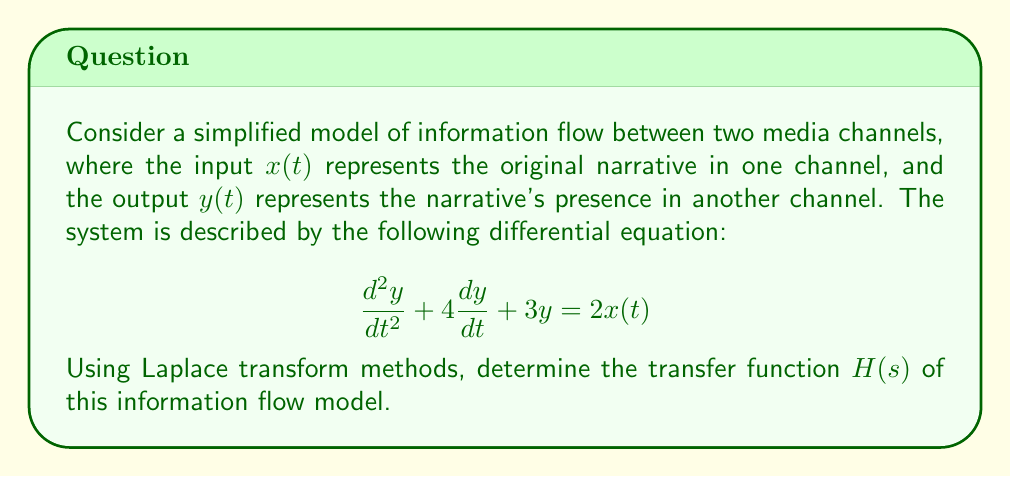Can you answer this question? To find the transfer function using Laplace transform methods, we follow these steps:

1) First, we take the Laplace transform of both sides of the differential equation. Let $X(s)$ and $Y(s)$ be the Laplace transforms of $x(t)$ and $y(t)$ respectively.

   $$\mathcal{L}\left\{\frac{d^2y}{dt^2} + 4\frac{dy}{dt} + 3y\right\} = \mathcal{L}\{2x(t)\}$$

2) Using the properties of Laplace transforms:

   $$s^2Y(s) - sy(0) - y'(0) + 4[sY(s) - y(0)] + 3Y(s) = 2X(s)$$

3) Assuming zero initial conditions (i.e., $y(0) = 0$ and $y'(0) = 0$), we get:

   $$s^2Y(s) + 4sY(s) + 3Y(s) = 2X(s)$$

4) Factoring out $Y(s)$:

   $$Y(s)(s^2 + 4s + 3) = 2X(s)$$

5) The transfer function $H(s)$ is defined as the ratio of output to input in the s-domain:

   $$H(s) = \frac{Y(s)}{X(s)} = \frac{2}{s^2 + 4s + 3}$$

This transfer function represents how the narrative is transferred or adapted between the two media channels in this simplified model.
Answer: $$H(s) = \frac{2}{s^2 + 4s + 3}$$ 